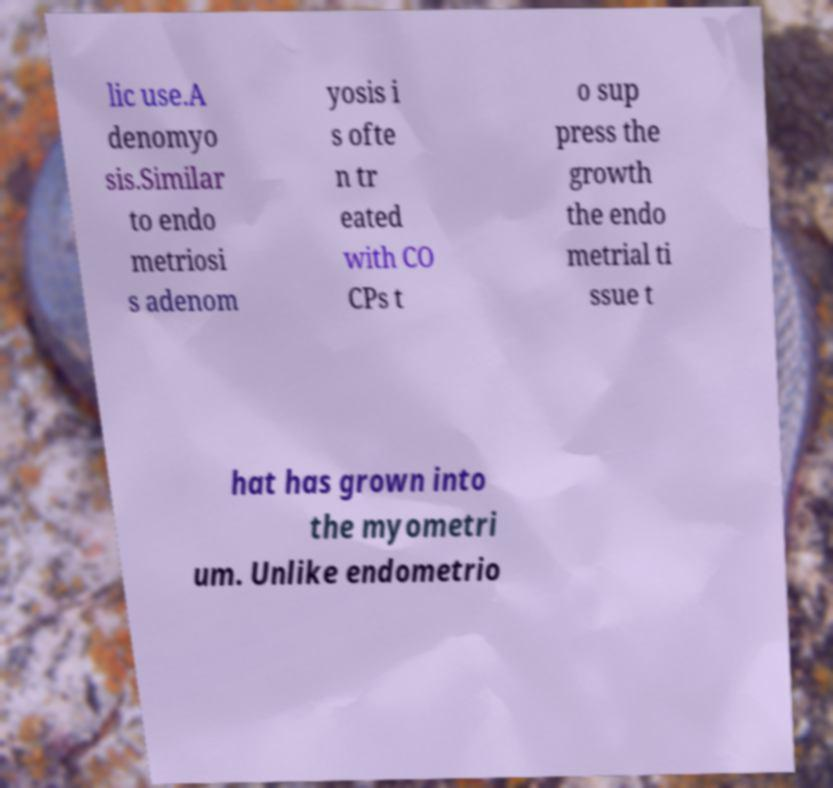Could you assist in decoding the text presented in this image and type it out clearly? lic use.A denomyo sis.Similar to endo metriosi s adenom yosis i s ofte n tr eated with CO CPs t o sup press the growth the endo metrial ti ssue t hat has grown into the myometri um. Unlike endometrio 